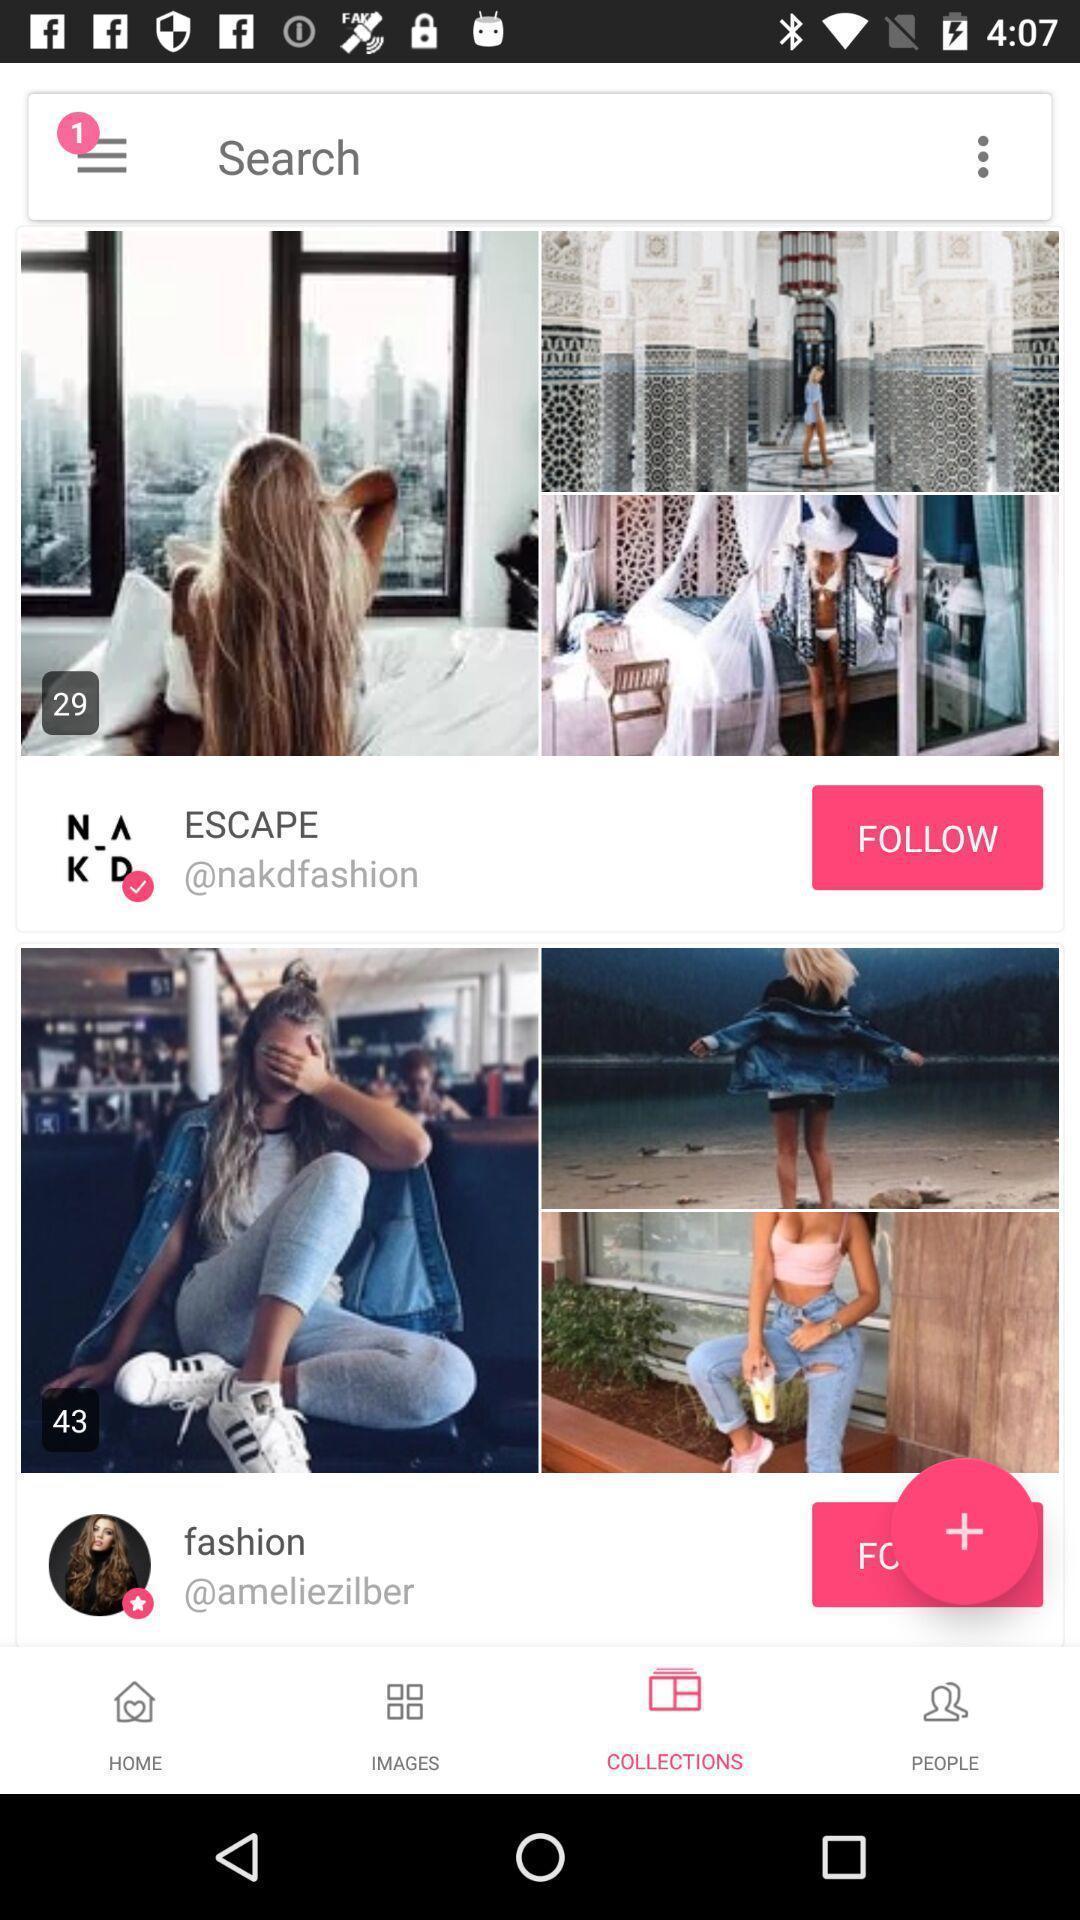Give me a summary of this screen capture. Page showing collections with search bar. 